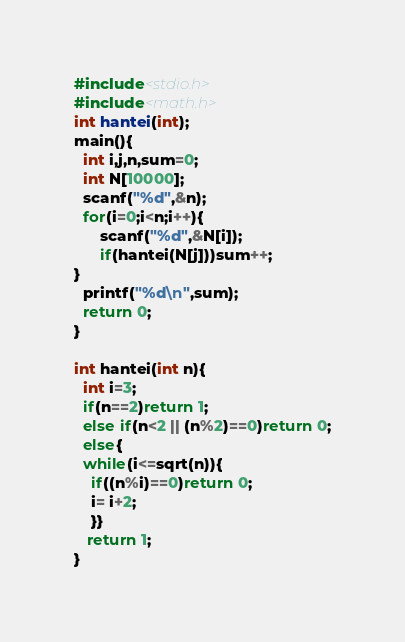<code> <loc_0><loc_0><loc_500><loc_500><_C_>#include<stdio.h>
#include<math.h>
int hantei(int);
main(){
  int i,j,n,sum=0;
  int N[10000];
  scanf("%d",&n);
  for(i=0;i<n;i++){ 
      scanf("%d",&N[i]);
      if(hantei(N[j]))sum++; 
} 
  printf("%d\n",sum);
  return 0;
}

int hantei(int n){
  int i=3;
  if(n==2)return 1;
  else if(n<2 || (n%2)==0)return 0;
  else{
  while(i<=sqrt(n)){
    if((n%i)==0)return 0;
    i= i+2;
    }}
   return 1;
}</code> 